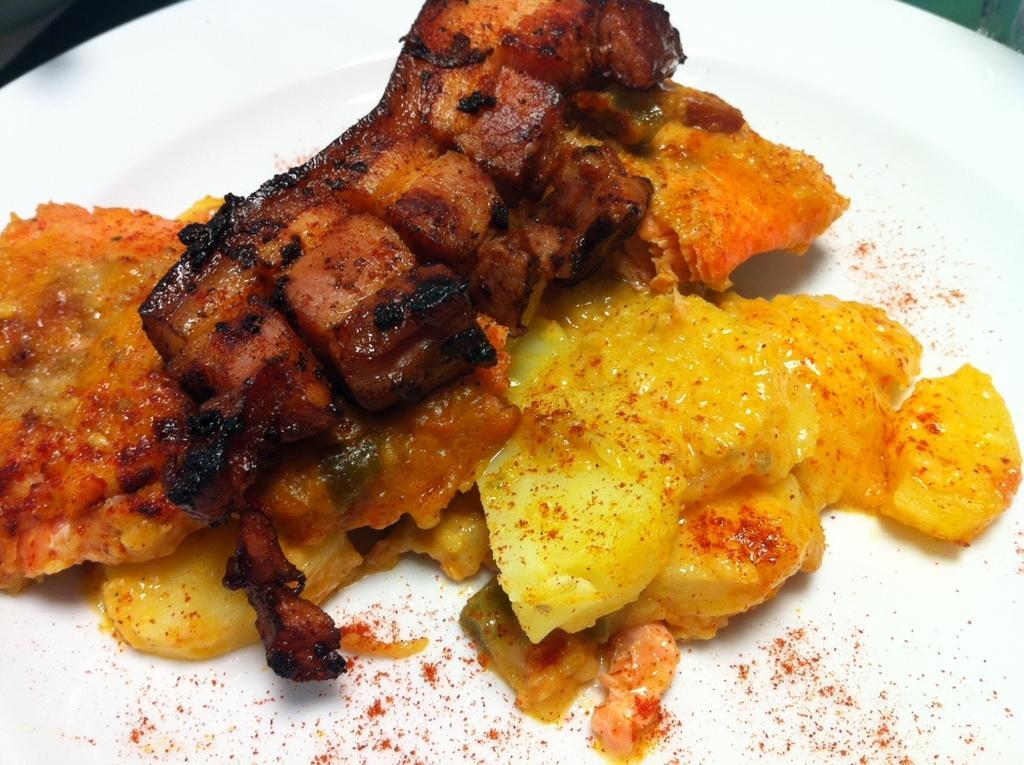How would you summarize this image in a sentence or two? In the foreground of this image, there is a food item on a white platter. 